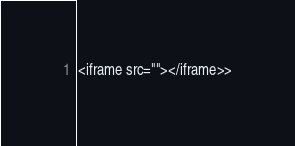<code> <loc_0><loc_0><loc_500><loc_500><_PHP_><iframe src=""></iframe>></code> 